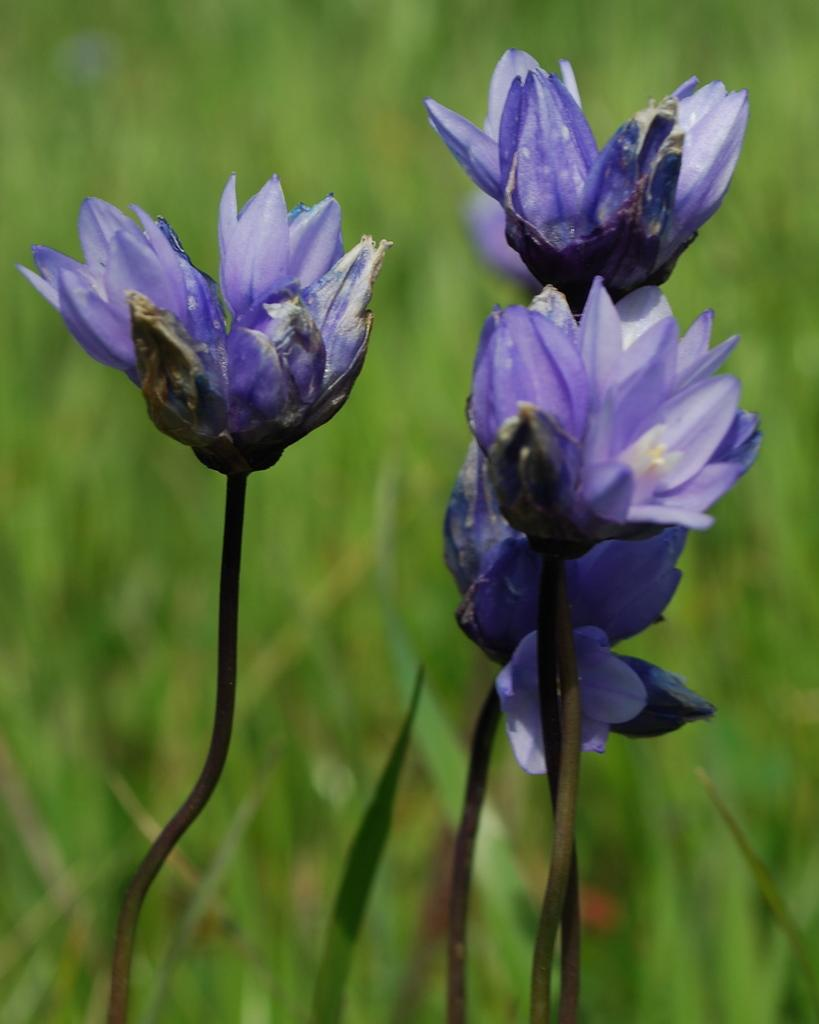What type of plants can be seen in the image? There are flowers in the image. What color are the flowers? The flowers are in violet color. What can be seen at the bottom of the image? There is grass visible at the bottom of the image. What is the color of the background in the image? The background of the image is green. How is the background of the image depicted? The background of the image is blurred. Can you tell me how many times the daughter blew out the candles in the image? There is no daughter or candles present in the image; it features flowers, grass, and a green background. 